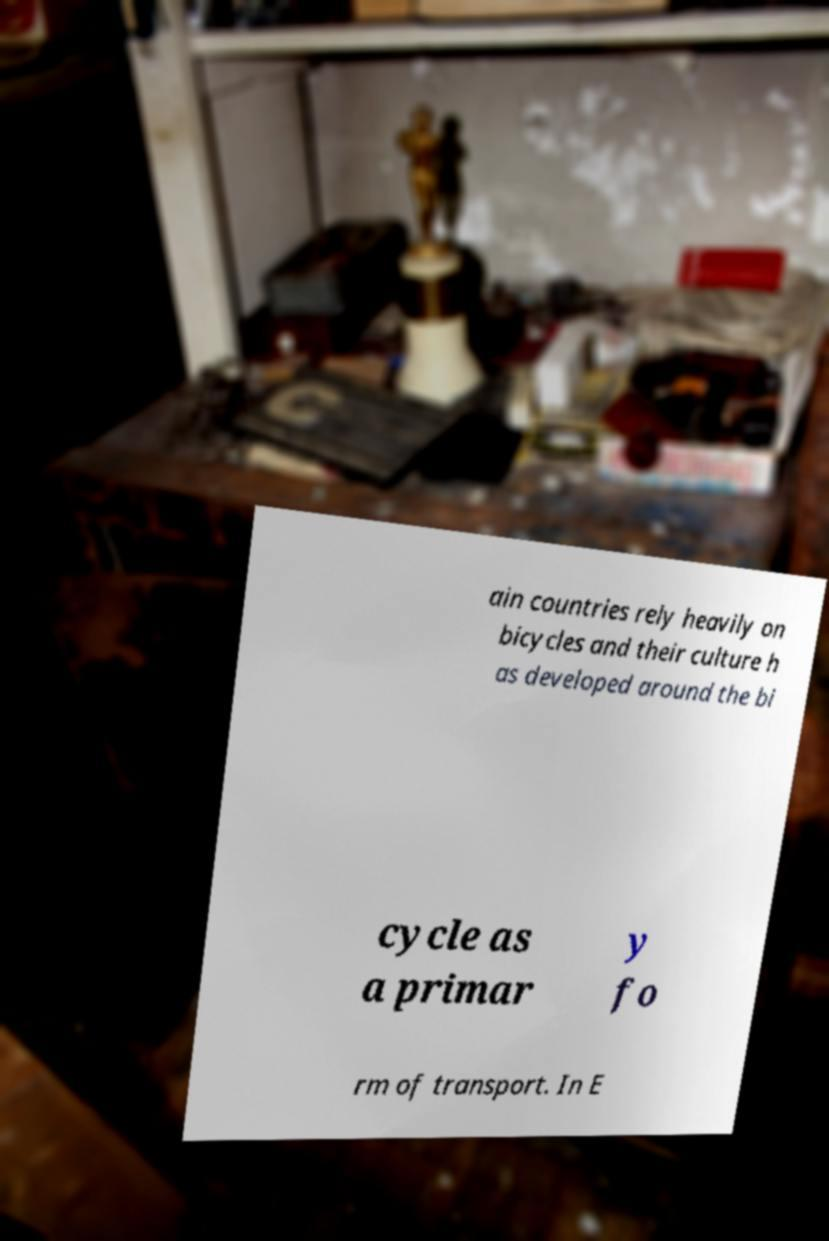There's text embedded in this image that I need extracted. Can you transcribe it verbatim? ain countries rely heavily on bicycles and their culture h as developed around the bi cycle as a primar y fo rm of transport. In E 